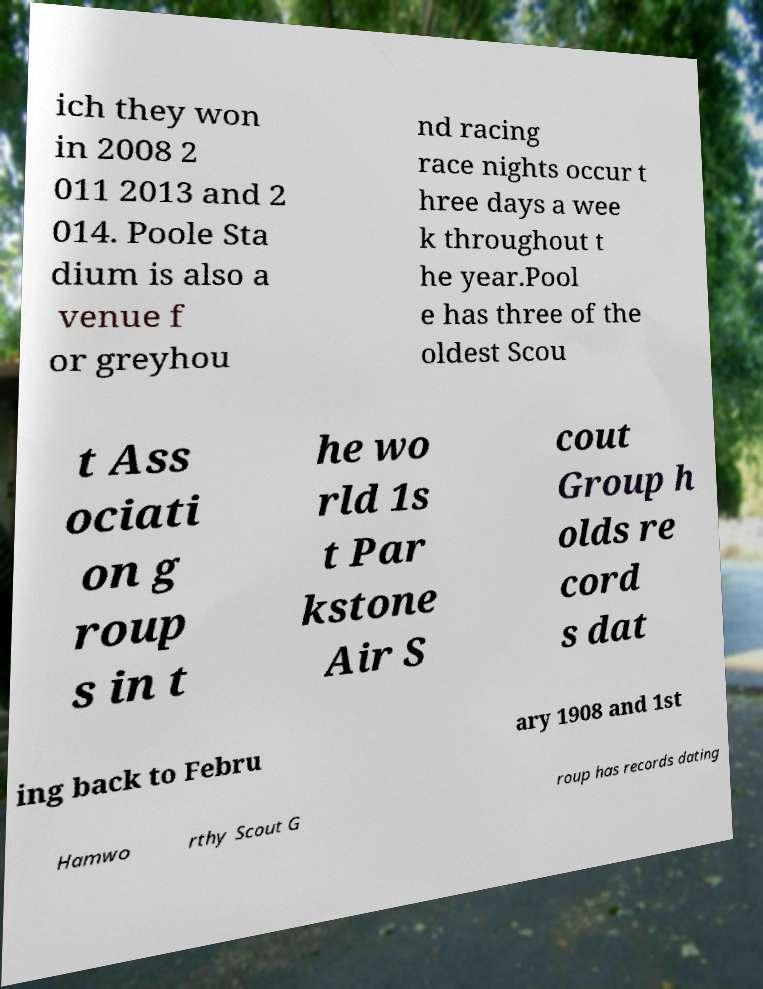I need the written content from this picture converted into text. Can you do that? ich they won in 2008 2 011 2013 and 2 014. Poole Sta dium is also a venue f or greyhou nd racing race nights occur t hree days a wee k throughout t he year.Pool e has three of the oldest Scou t Ass ociati on g roup s in t he wo rld 1s t Par kstone Air S cout Group h olds re cord s dat ing back to Febru ary 1908 and 1st Hamwo rthy Scout G roup has records dating 